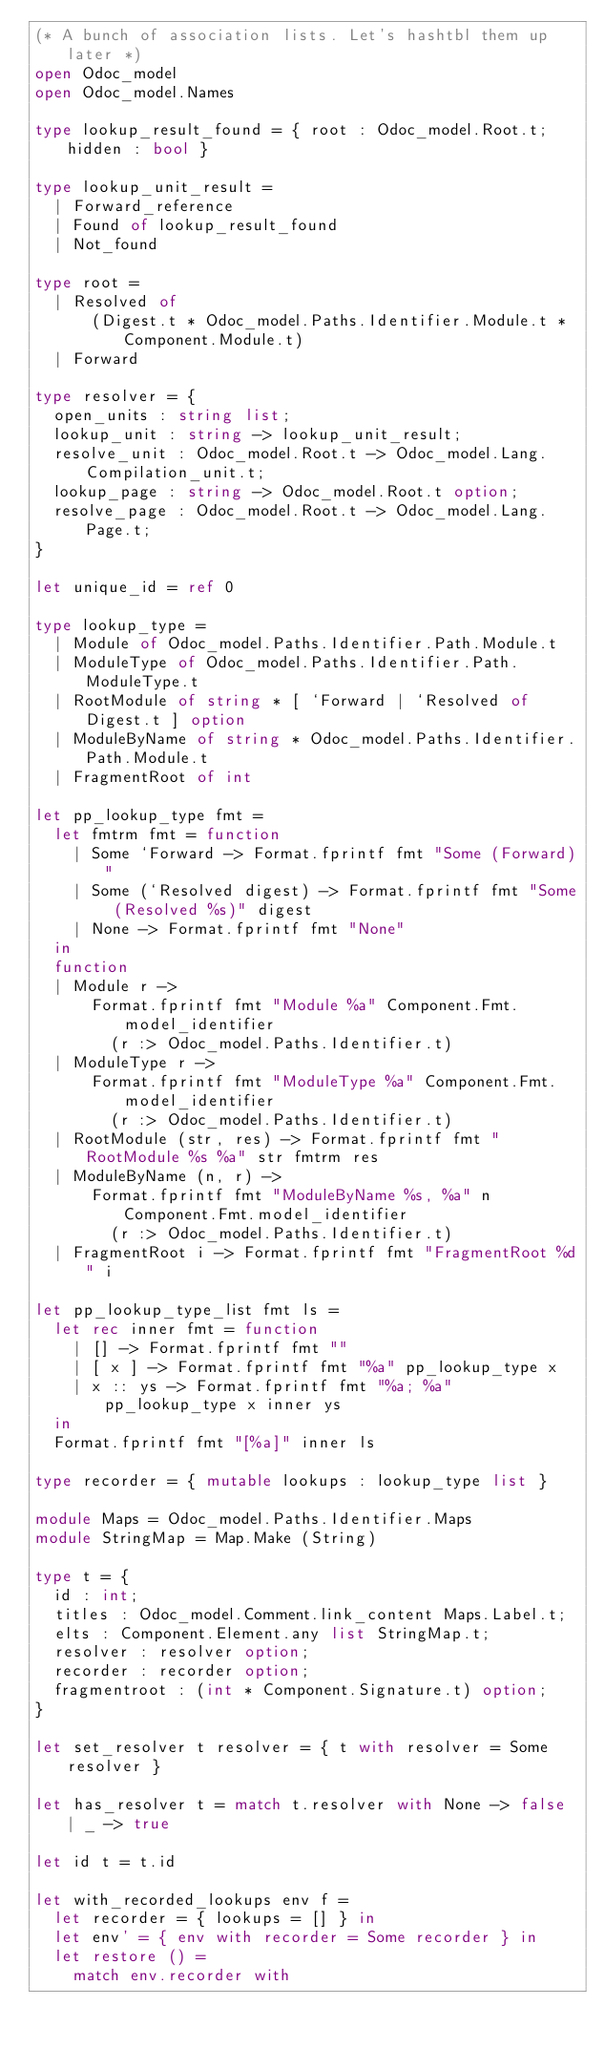Convert code to text. <code><loc_0><loc_0><loc_500><loc_500><_OCaml_>(* A bunch of association lists. Let's hashtbl them up later *)
open Odoc_model
open Odoc_model.Names

type lookup_result_found = { root : Odoc_model.Root.t; hidden : bool }

type lookup_unit_result =
  | Forward_reference
  | Found of lookup_result_found
  | Not_found

type root =
  | Resolved of
      (Digest.t * Odoc_model.Paths.Identifier.Module.t * Component.Module.t)
  | Forward

type resolver = {
  open_units : string list;
  lookup_unit : string -> lookup_unit_result;
  resolve_unit : Odoc_model.Root.t -> Odoc_model.Lang.Compilation_unit.t;
  lookup_page : string -> Odoc_model.Root.t option;
  resolve_page : Odoc_model.Root.t -> Odoc_model.Lang.Page.t;
}

let unique_id = ref 0

type lookup_type =
  | Module of Odoc_model.Paths.Identifier.Path.Module.t
  | ModuleType of Odoc_model.Paths.Identifier.Path.ModuleType.t
  | RootModule of string * [ `Forward | `Resolved of Digest.t ] option
  | ModuleByName of string * Odoc_model.Paths.Identifier.Path.Module.t
  | FragmentRoot of int

let pp_lookup_type fmt =
  let fmtrm fmt = function
    | Some `Forward -> Format.fprintf fmt "Some (Forward)"
    | Some (`Resolved digest) -> Format.fprintf fmt "Some (Resolved %s)" digest
    | None -> Format.fprintf fmt "None"
  in
  function
  | Module r ->
      Format.fprintf fmt "Module %a" Component.Fmt.model_identifier
        (r :> Odoc_model.Paths.Identifier.t)
  | ModuleType r ->
      Format.fprintf fmt "ModuleType %a" Component.Fmt.model_identifier
        (r :> Odoc_model.Paths.Identifier.t)
  | RootModule (str, res) -> Format.fprintf fmt "RootModule %s %a" str fmtrm res
  | ModuleByName (n, r) ->
      Format.fprintf fmt "ModuleByName %s, %a" n Component.Fmt.model_identifier
        (r :> Odoc_model.Paths.Identifier.t)
  | FragmentRoot i -> Format.fprintf fmt "FragmentRoot %d" i

let pp_lookup_type_list fmt ls =
  let rec inner fmt = function
    | [] -> Format.fprintf fmt ""
    | [ x ] -> Format.fprintf fmt "%a" pp_lookup_type x
    | x :: ys -> Format.fprintf fmt "%a; %a" pp_lookup_type x inner ys
  in
  Format.fprintf fmt "[%a]" inner ls

type recorder = { mutable lookups : lookup_type list }

module Maps = Odoc_model.Paths.Identifier.Maps
module StringMap = Map.Make (String)

type t = {
  id : int;
  titles : Odoc_model.Comment.link_content Maps.Label.t;
  elts : Component.Element.any list StringMap.t;
  resolver : resolver option;
  recorder : recorder option;
  fragmentroot : (int * Component.Signature.t) option;
}

let set_resolver t resolver = { t with resolver = Some resolver }

let has_resolver t = match t.resolver with None -> false | _ -> true

let id t = t.id

let with_recorded_lookups env f =
  let recorder = { lookups = [] } in
  let env' = { env with recorder = Some recorder } in
  let restore () =
    match env.recorder with</code> 